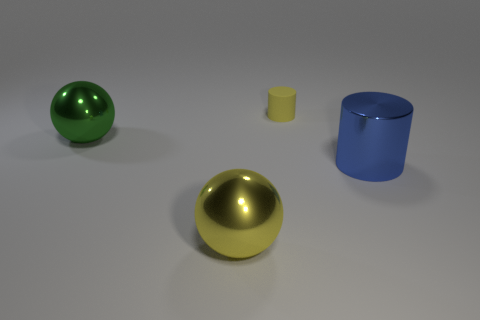Is there any other thing that has the same size as the rubber cylinder?
Your response must be concise. No. What number of things are large objects right of the rubber object or big objects to the left of the yellow rubber object?
Provide a succinct answer. 3. Are there any blue shiny objects of the same shape as the small yellow thing?
Offer a very short reply. Yes. What number of shiny things are either small yellow cylinders or big spheres?
Ensure brevity in your answer.  2. The green metal thing has what shape?
Make the answer very short. Sphere. What number of other things have the same material as the large green object?
Keep it short and to the point. 2. What is the color of the big cylinder that is made of the same material as the green sphere?
Make the answer very short. Blue. Do the yellow thing that is in front of the matte cylinder and the big blue metal cylinder have the same size?
Your response must be concise. Yes. There is another shiny object that is the same shape as the big green shiny thing; what color is it?
Ensure brevity in your answer.  Yellow. There is a big thing left of the yellow thing that is in front of the big green sphere in front of the small yellow cylinder; what is its shape?
Keep it short and to the point. Sphere. 